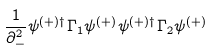Convert formula to latex. <formula><loc_0><loc_0><loc_500><loc_500>\frac { 1 } { \partial _ { - } ^ { 2 } } \psi ^ { ( + ) \dagger } \Gamma _ { 1 } \psi ^ { ( + ) } \psi ^ { ( + ) \dagger } \Gamma _ { 2 } \psi ^ { ( + ) }</formula> 